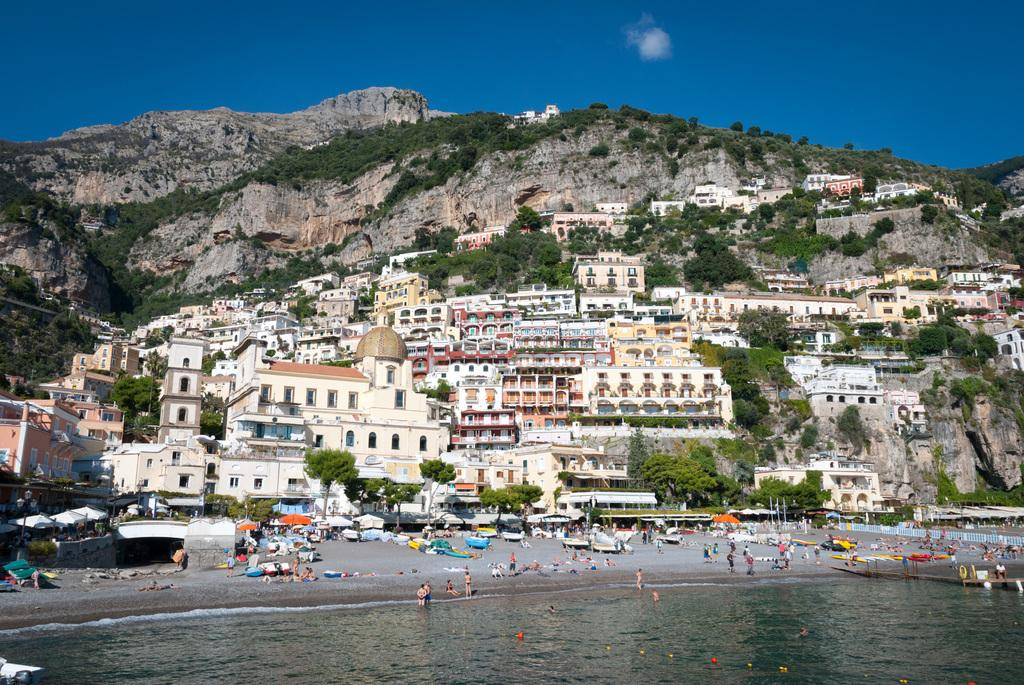What type of natural feature is present in the image? There is a sea in the image. Are there any people in the image? Yes, there are people near the sea in the image. What structures can be seen in the image? There are tents, trees, and buildings in the image. What is the largest landform in the image? There is a mountain in the image. What is visible in the sky in the image? The sky is visible in the image. What is the name of the animal that can be seen curving around the mountain in the image? There are no animals visible in the image, and the mountain does not have any curves. 